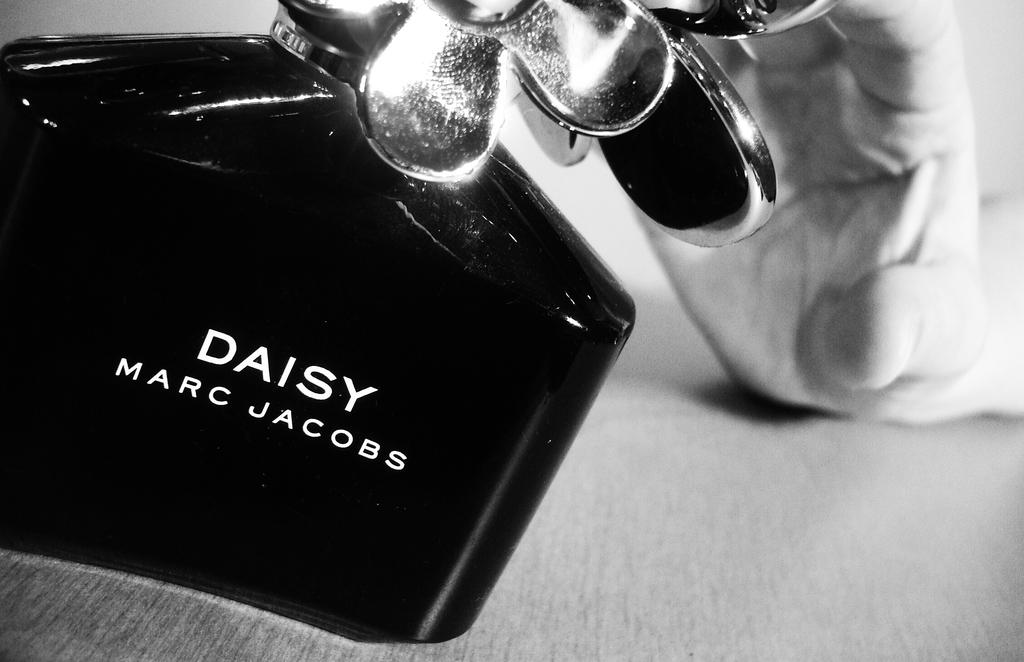<image>
Provide a brief description of the given image. A bottle of perfume called Daisy Marc Jacobs. 